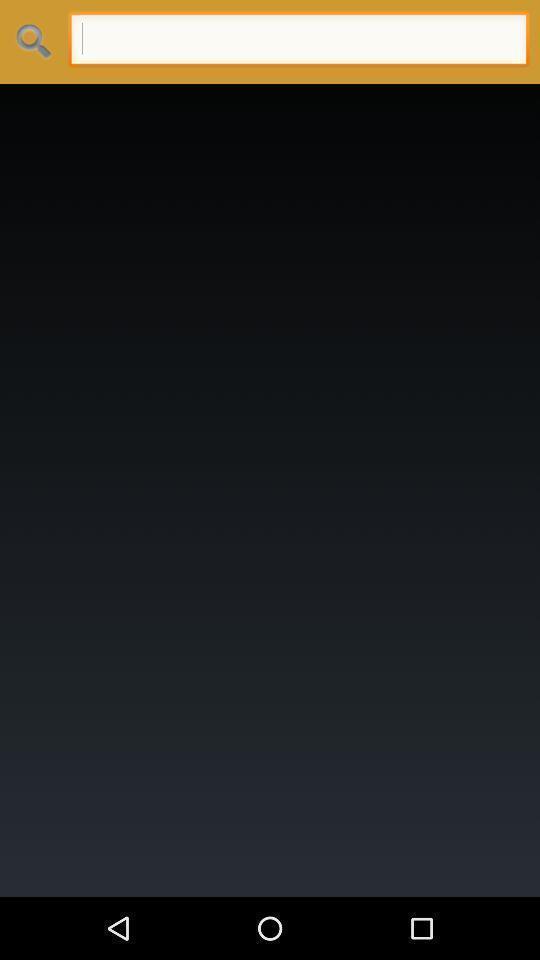What is the overall content of this screenshot? Search bar and blank page displayed. 